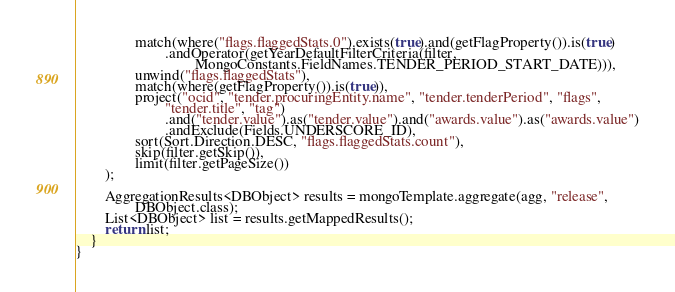Convert code to text. <code><loc_0><loc_0><loc_500><loc_500><_Java_>                match(where("flags.flaggedStats.0").exists(true).and(getFlagProperty()).is(true)
                        .andOperator(getYearDefaultFilterCriteria(filter,
                                MongoConstants.FieldNames.TENDER_PERIOD_START_DATE))),
                unwind("flags.flaggedStats"),
                match(where(getFlagProperty()).is(true)),
                project("ocid", "tender.procuringEntity.name", "tender.tenderPeriod", "flags",
                        "tender.title", "tag")
                        .and("tender.value").as("tender.value").and("awards.value").as("awards.value")
                        .andExclude(Fields.UNDERSCORE_ID),
                sort(Sort.Direction.DESC, "flags.flaggedStats.count"),
                skip(filter.getSkip()),
                limit(filter.getPageSize())
        );

        AggregationResults<DBObject> results = mongoTemplate.aggregate(agg, "release",
                DBObject.class);
        List<DBObject> list = results.getMappedResults();
        return list;
    }
}
</code> 